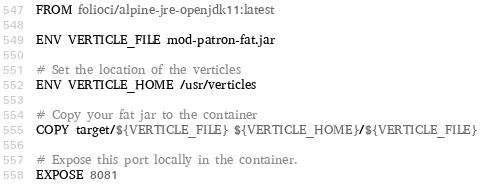<code> <loc_0><loc_0><loc_500><loc_500><_Dockerfile_>FROM folioci/alpine-jre-openjdk11:latest

ENV VERTICLE_FILE mod-patron-fat.jar

# Set the location of the verticles
ENV VERTICLE_HOME /usr/verticles

# Copy your fat jar to the container
COPY target/${VERTICLE_FILE} ${VERTICLE_HOME}/${VERTICLE_FILE}

# Expose this port locally in the container.
EXPOSE 8081
</code> 